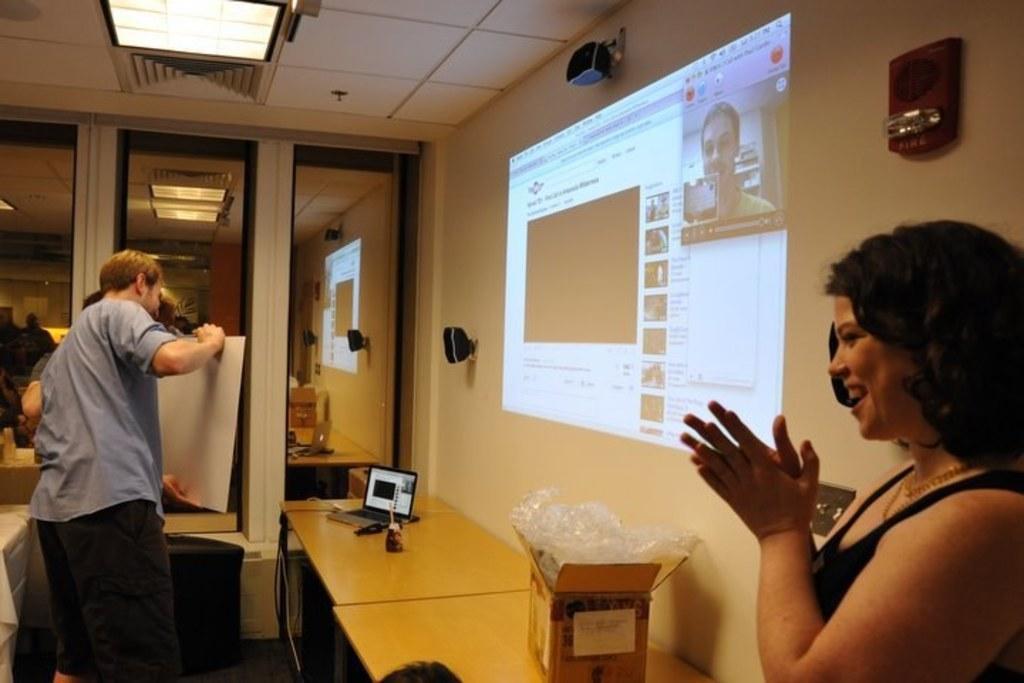Could you give a brief overview of what you see in this image? In this image on the right side there is one woman who is standing, and she is clapping. On the left side there are two persons who are standing, and they are holding a board. In the center there is one table, on the table there is one box, laptop and some wires and in the background there are some glass windows, lights, boxes and a wall. In the center there is a screen, and on the top there is ceiling and lights and on the wall there are some speakers. 